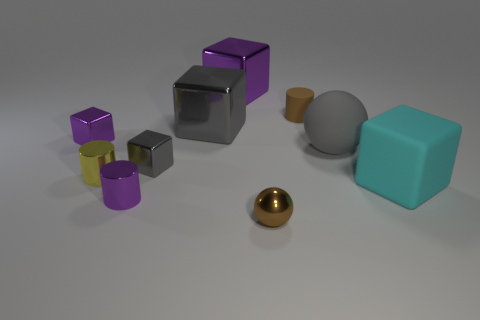What is the color of the small rubber cylinder?
Keep it short and to the point. Brown. Is there a small brown object that is behind the large gray object right of the big purple cube?
Make the answer very short. Yes. What is the big ball made of?
Give a very brief answer. Rubber. Does the small purple thing behind the purple cylinder have the same material as the small cylinder that is behind the big sphere?
Provide a succinct answer. No. Are there any other things that are the same color as the tiny matte cylinder?
Give a very brief answer. Yes. There is another tiny metallic object that is the same shape as the yellow shiny thing; what color is it?
Your answer should be compact. Purple. There is a purple thing that is in front of the small matte cylinder and to the right of the small purple metal cube; what is its size?
Keep it short and to the point. Small. There is a tiny thing on the right side of the tiny brown metallic sphere; does it have the same shape as the large shiny object behind the tiny rubber cylinder?
Offer a very short reply. No. What is the shape of the rubber object that is the same color as the small sphere?
Offer a very short reply. Cylinder. What number of big purple blocks are made of the same material as the tiny purple cylinder?
Your response must be concise. 1. 